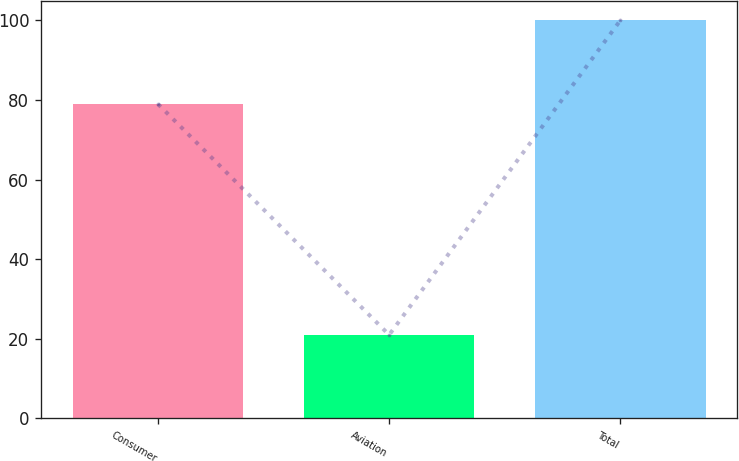Convert chart to OTSL. <chart><loc_0><loc_0><loc_500><loc_500><bar_chart><fcel>Consumer<fcel>Aviation<fcel>Total<nl><fcel>79<fcel>21<fcel>100<nl></chart> 